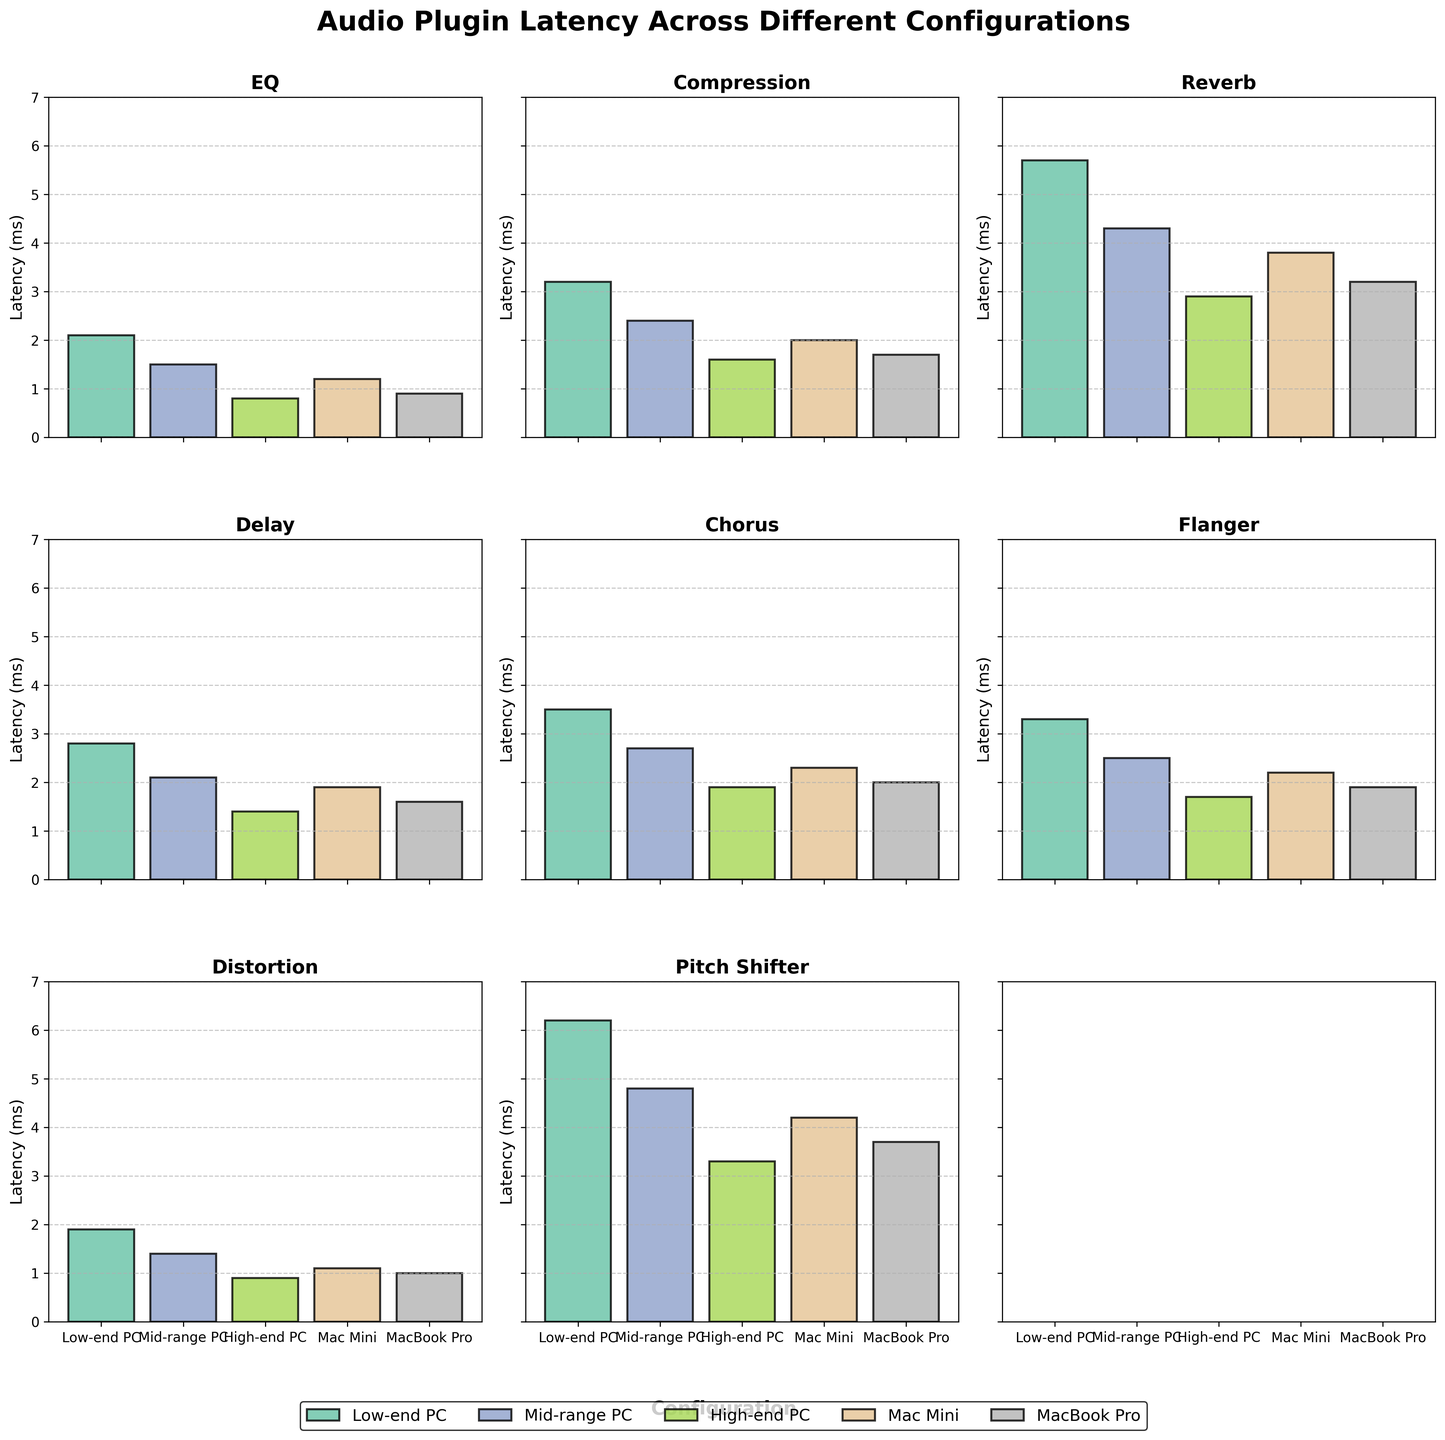What's the lowest plugin latency across all configurations? To find the lowest latency, we need to look at the minimum height among all the bars in all subplots. The lowest bar corresponds to the EQ plugin on the High-end PC configuration with a latency of 0.8 ms.
Answer: 0.8 ms Which plugin has the highest latency on the Low-end PC configuration? The bar with the greatest height in the Low-end PC configuration will indicate the highest latency. For the Low-end PC, the Pitch Shifter plugin has the highest bar with a latency of 6.2 ms.
Answer: Pitch Shifter How does the latency of the Compression plugin compare between the Low-end PC and the Mac Mini? We need to compare the heights of the bars for the Compression plugin on Low-end PC and Mac Mini configurations. On the Low-end PC, the latency is 3.2 ms, while on the Mac Mini, the latency is 2.0 ms. Therefore, the latency on the Low-end PC is greater.
Answer: Latency on Low-end PC is greater What is the average latency for the Reverb plugin across all configurations? To calculate the average, sum up the latencies of the Reverb plugin across all configurations (5.7 + 4.3 + 2.9 + 3.8 + 3.2) and then divide by the number of configurations (5). (5.7 + 4.3 + 2.9 + 3.8 + 3.2) = 19.9. Therefore, 19.9 / 5 = 3.98 ms.
Answer: 3.98 ms Is the latency of the Distortion plugin on the High-end PC less than on the Mid-range PC? We compare the heights of the bars for the Distortion plugin on High-end PC and Mid-range PC configurations. The latency for the Distortion plugin on High-end PC is 0.9 ms, while on the Mid-range PC, it's 1.4 ms. Therefore, it is less on the High-end PC.
Answer: Yes Which configuration consistently shows the lowest latencies across all plugins? To find this, observe the bar heights across all plugins and note which configuration has the generally smallest bars. The High-end PC consistently shows the lowest latencies across all plugins.
Answer: High-end PC What is the difference in latency between the Reverb plugin and the Delay plugin on the MacBook Pro? Subtract the latency of the Delay plugin from that of the Reverb plugin on the MacBook Pro. For the Reverb plugin, the latency is 3.2 ms, and for the Delay plugin, it is 1.6 ms. Therefore, 3.2 - 1.6 = 1.6 ms.
Answer: 1.6 ms Which plugin type shows the greatest variability in latency across different configurations? To determine variability, look at the range of latency values for each plugin type. Reverb shows the greatest variability, with latencies ranging from 5.7 ms on the Low-end PC to 2.9 ms on the High-end PC (a range of 2.8 ms).
Answer: Reverb Does the Mac Mini configuration consistently have higher latency than the MacBook Pro across all plugins? Compare the bar heights of the Mac Mini with the MacBook Pro across each plugin. The Mac Mini does not consistently have higher latencies; there are instances where latencies are similar or lower in some plugins.
Answer: No 